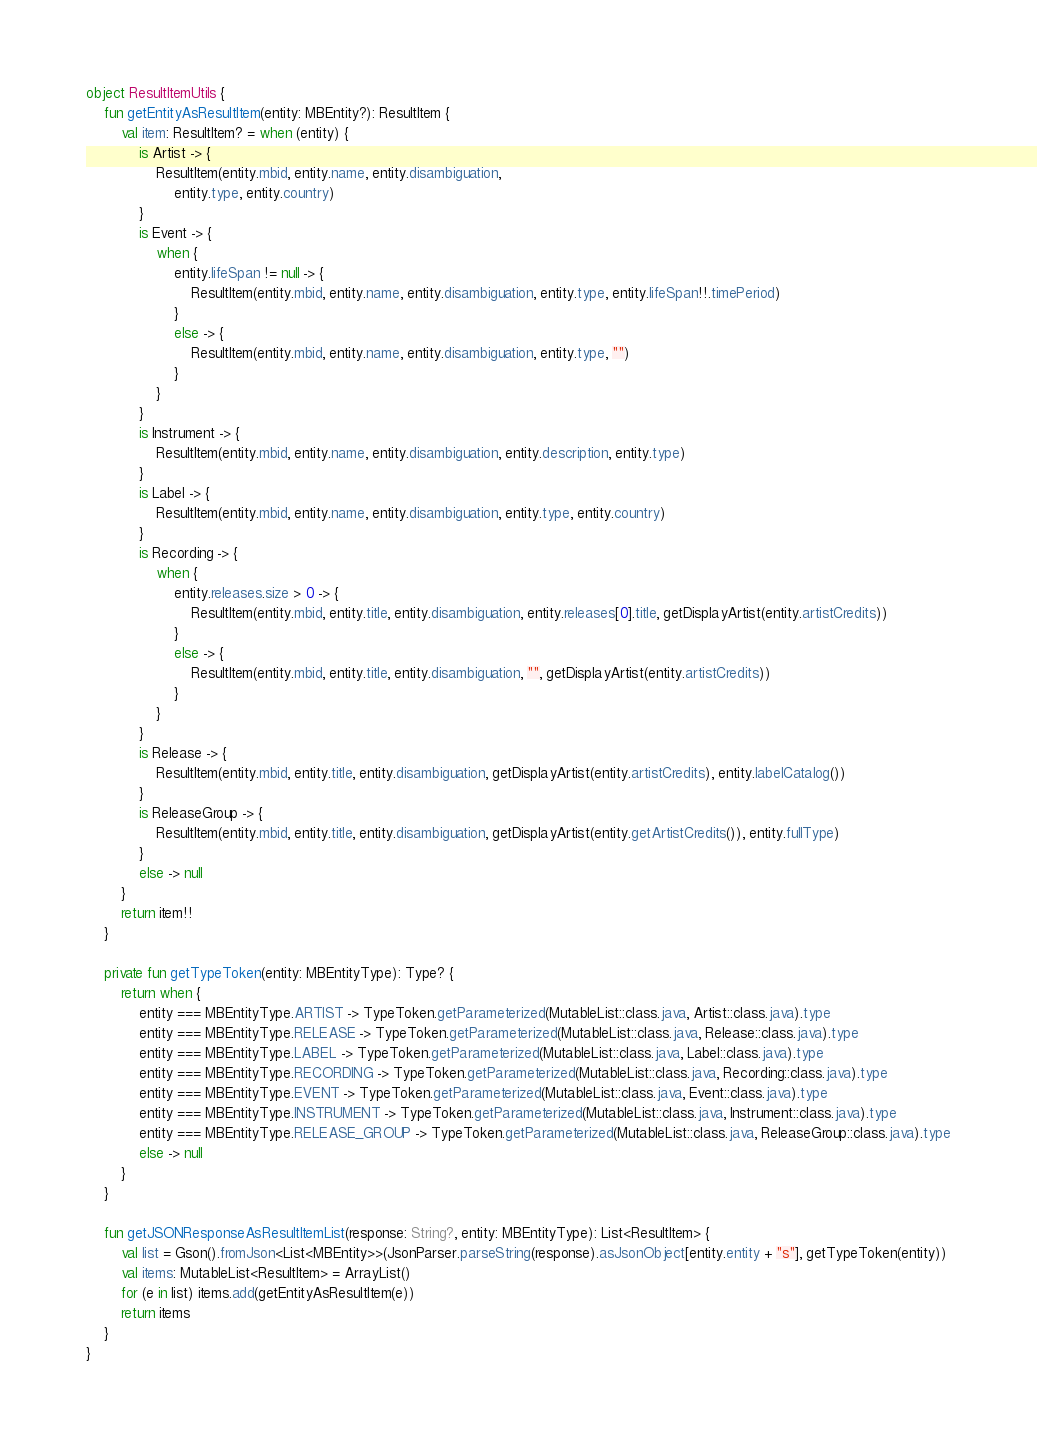Convert code to text. <code><loc_0><loc_0><loc_500><loc_500><_Kotlin_>object ResultItemUtils {
    fun getEntityAsResultItem(entity: MBEntity?): ResultItem {
        val item: ResultItem? = when (entity) {
            is Artist -> {
                ResultItem(entity.mbid, entity.name, entity.disambiguation,
                    entity.type, entity.country)
            }
            is Event -> {
                when {
                    entity.lifeSpan != null -> {
                        ResultItem(entity.mbid, entity.name, entity.disambiguation, entity.type, entity.lifeSpan!!.timePeriod)
                    }
                    else -> {
                        ResultItem(entity.mbid, entity.name, entity.disambiguation, entity.type, "")
                    }
                }
            }
            is Instrument -> {
                ResultItem(entity.mbid, entity.name, entity.disambiguation, entity.description, entity.type)
            }
            is Label -> {
                ResultItem(entity.mbid, entity.name, entity.disambiguation, entity.type, entity.country)
            }
            is Recording -> {
                when {
                    entity.releases.size > 0 -> {
                        ResultItem(entity.mbid, entity.title, entity.disambiguation, entity.releases[0].title, getDisplayArtist(entity.artistCredits))
                    }
                    else -> {
                        ResultItem(entity.mbid, entity.title, entity.disambiguation, "", getDisplayArtist(entity.artistCredits))
                    }
                }
            }
            is Release -> {
                ResultItem(entity.mbid, entity.title, entity.disambiguation, getDisplayArtist(entity.artistCredits), entity.labelCatalog())
            }
            is ReleaseGroup -> {
                ResultItem(entity.mbid, entity.title, entity.disambiguation, getDisplayArtist(entity.getArtistCredits()), entity.fullType)
            }
            else -> null
        }
        return item!!
    }

    private fun getTypeToken(entity: MBEntityType): Type? {
        return when {
            entity === MBEntityType.ARTIST -> TypeToken.getParameterized(MutableList::class.java, Artist::class.java).type
            entity === MBEntityType.RELEASE -> TypeToken.getParameterized(MutableList::class.java, Release::class.java).type
            entity === MBEntityType.LABEL -> TypeToken.getParameterized(MutableList::class.java, Label::class.java).type
            entity === MBEntityType.RECORDING -> TypeToken.getParameterized(MutableList::class.java, Recording::class.java).type
            entity === MBEntityType.EVENT -> TypeToken.getParameterized(MutableList::class.java, Event::class.java).type
            entity === MBEntityType.INSTRUMENT -> TypeToken.getParameterized(MutableList::class.java, Instrument::class.java).type
            entity === MBEntityType.RELEASE_GROUP -> TypeToken.getParameterized(MutableList::class.java, ReleaseGroup::class.java).type
            else -> null
        }
    }

    fun getJSONResponseAsResultItemList(response: String?, entity: MBEntityType): List<ResultItem> {
        val list = Gson().fromJson<List<MBEntity>>(JsonParser.parseString(response).asJsonObject[entity.entity + "s"], getTypeToken(entity))
        val items: MutableList<ResultItem> = ArrayList()
        for (e in list) items.add(getEntityAsResultItem(e))
        return items
    }
}</code> 